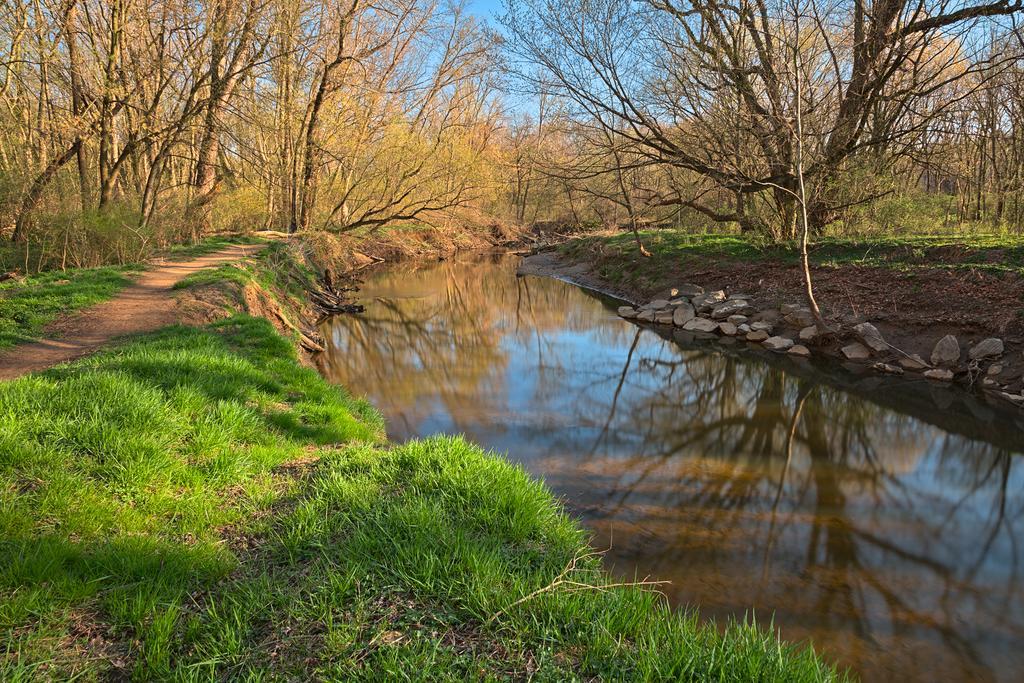Please provide a concise description of this image. In the center of the image we can see a canal. At the bottom there is grass. In the background there are trees and we can see rocks. There is sky. 